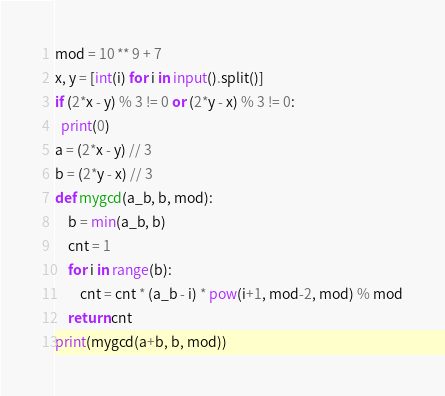Convert code to text. <code><loc_0><loc_0><loc_500><loc_500><_Python_>mod = 10 ** 9 + 7
x, y = [int(i) for i in input().split()]
if (2*x - y) % 3 != 0 or (2*y - x) % 3 != 0:
  print(0)
a = (2*x - y) // 3
b = (2*y - x) // 3
def mygcd(a_b, b, mod):
    b = min(a_b, b)
    cnt = 1
    for i in range(b):
        cnt = cnt * (a_b - i) * pow(i+1, mod-2, mod) % mod
    return cnt
print(mygcd(a+b, b, mod))</code> 